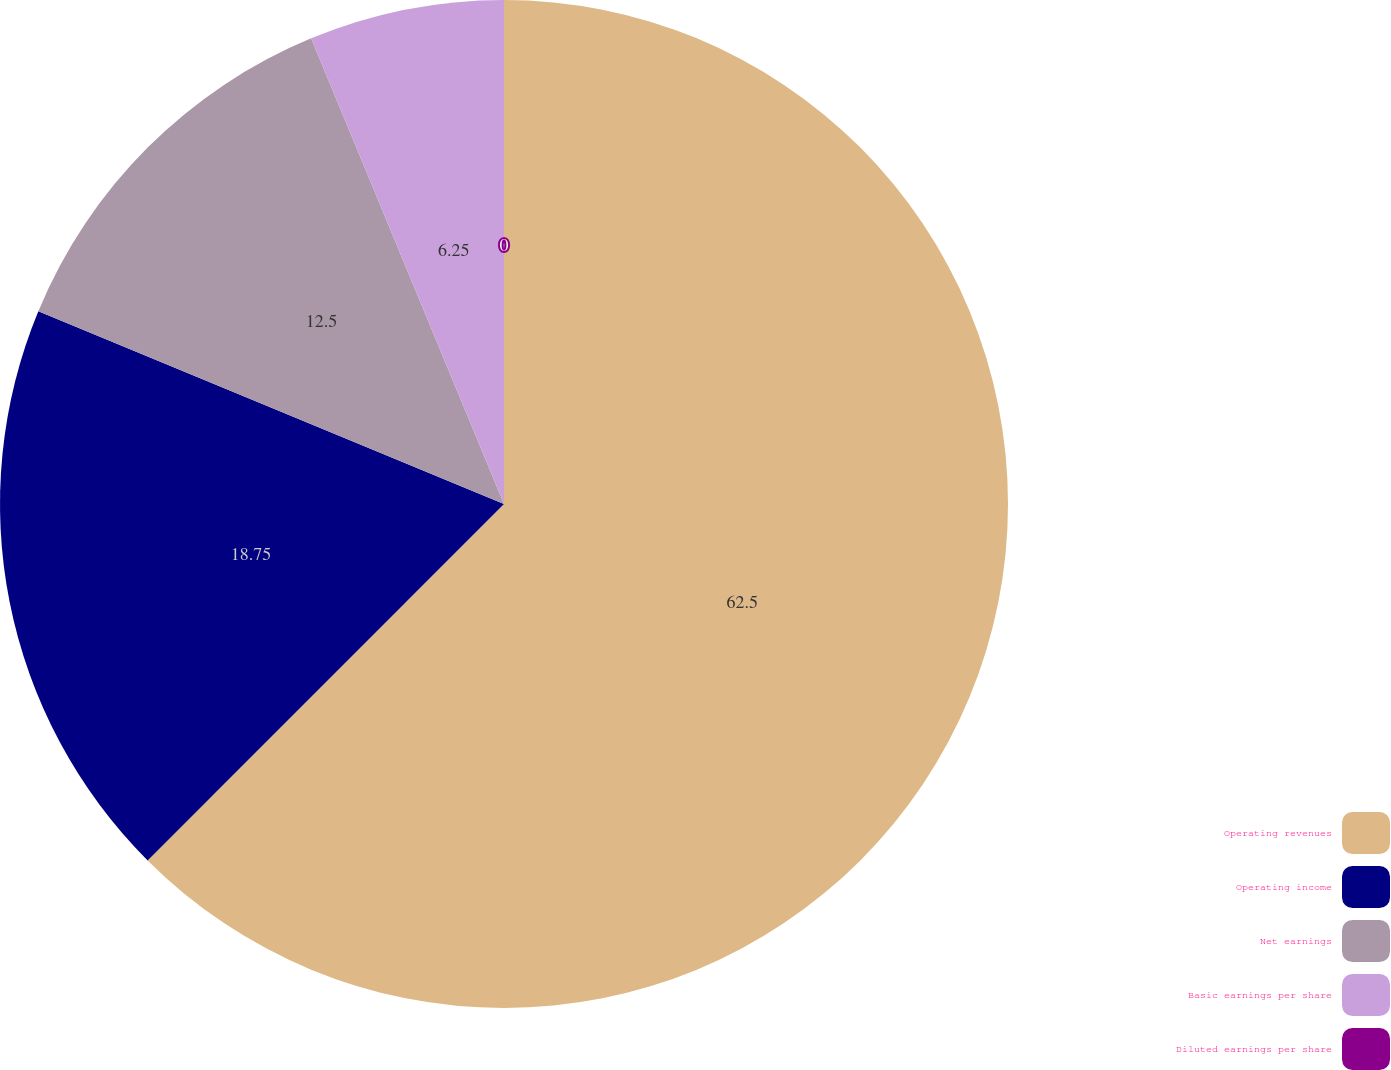<chart> <loc_0><loc_0><loc_500><loc_500><pie_chart><fcel>Operating revenues<fcel>Operating income<fcel>Net earnings<fcel>Basic earnings per share<fcel>Diluted earnings per share<nl><fcel>62.5%<fcel>18.75%<fcel>12.5%<fcel>6.25%<fcel>0.0%<nl></chart> 